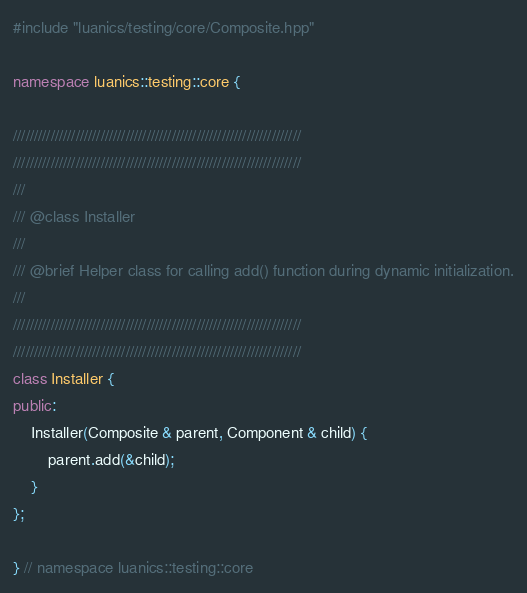<code> <loc_0><loc_0><loc_500><loc_500><_C++_>#include "luanics/testing/core/Composite.hpp"

namespace luanics::testing::core {

/////////////////////////////////////////////////////////////////////
/////////////////////////////////////////////////////////////////////
///
/// @class Installer
///
/// @brief Helper class for calling add() function during dynamic initialization.
///
/////////////////////////////////////////////////////////////////////
/////////////////////////////////////////////////////////////////////
class Installer {
public:
	Installer(Composite & parent, Component & child) {
		parent.add(&child);
	}
};

} // namespace luanics::testing::core
</code> 